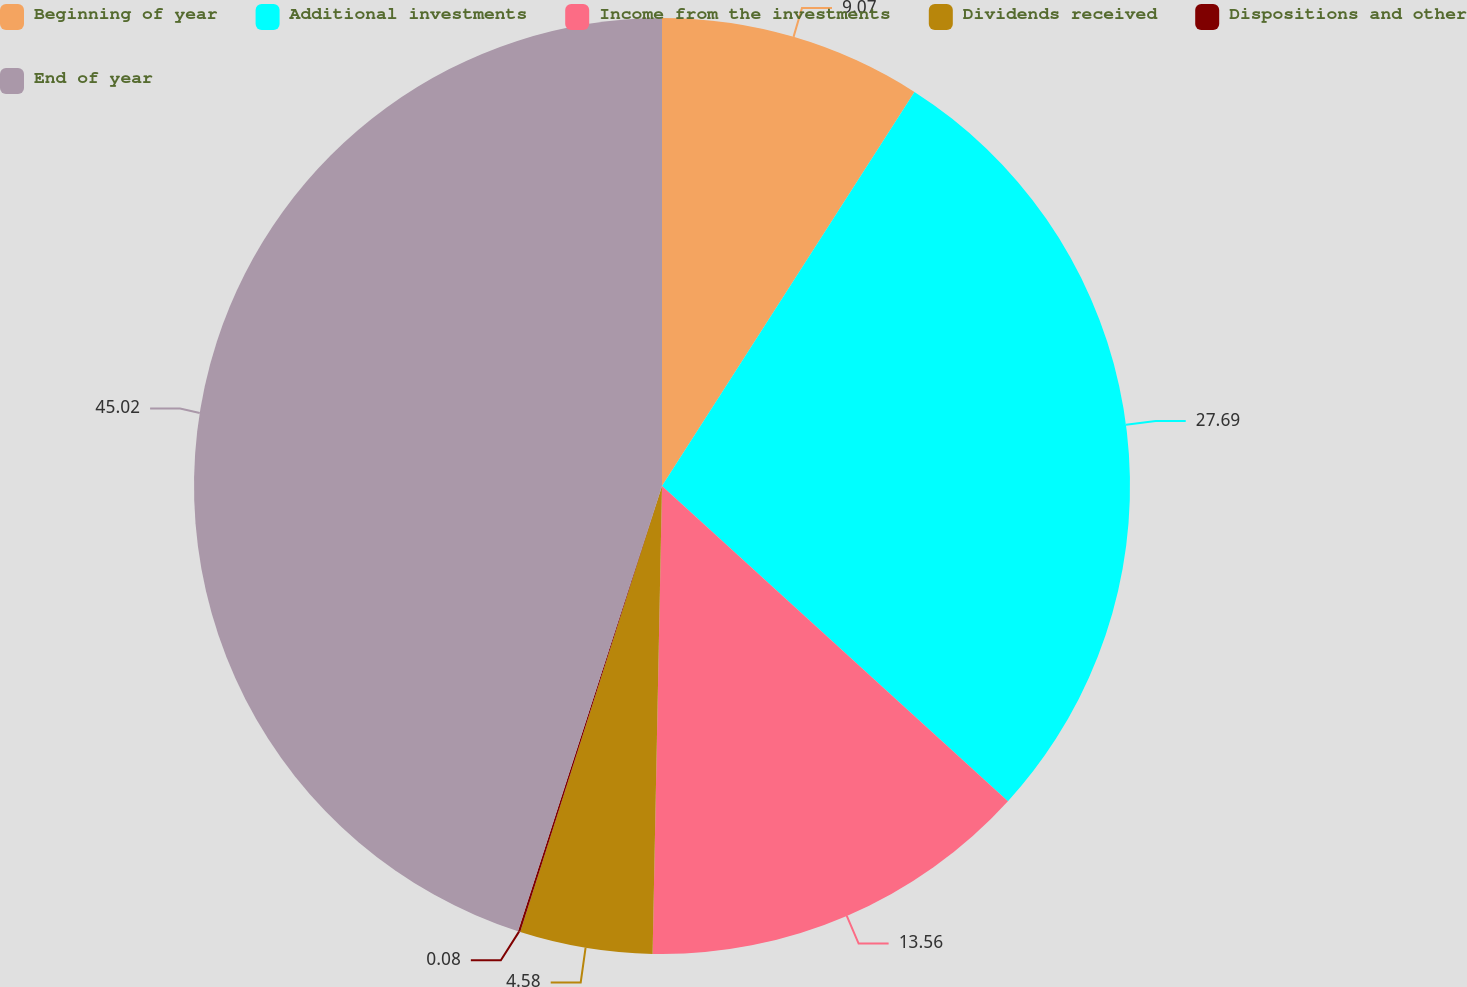Convert chart to OTSL. <chart><loc_0><loc_0><loc_500><loc_500><pie_chart><fcel>Beginning of year<fcel>Additional investments<fcel>Income from the investments<fcel>Dividends received<fcel>Dispositions and other<fcel>End of year<nl><fcel>9.07%<fcel>27.69%<fcel>13.56%<fcel>4.58%<fcel>0.08%<fcel>45.02%<nl></chart> 